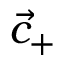Convert formula to latex. <formula><loc_0><loc_0><loc_500><loc_500>{ \vec { c } } _ { + }</formula> 